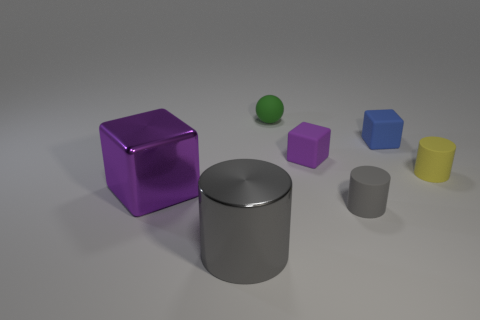Subtract all gray cylinders. How many were subtracted if there are1gray cylinders left? 1 Subtract all large purple blocks. How many blocks are left? 2 Subtract all blue cubes. How many cubes are left? 2 Add 3 large shiny objects. How many objects exist? 10 Subtract all spheres. How many objects are left? 6 Add 6 small purple metal cylinders. How many small purple metal cylinders exist? 6 Subtract 0 purple spheres. How many objects are left? 7 Subtract 3 cylinders. How many cylinders are left? 0 Subtract all yellow cylinders. Subtract all gray cubes. How many cylinders are left? 2 Subtract all brown cubes. How many gray cylinders are left? 2 